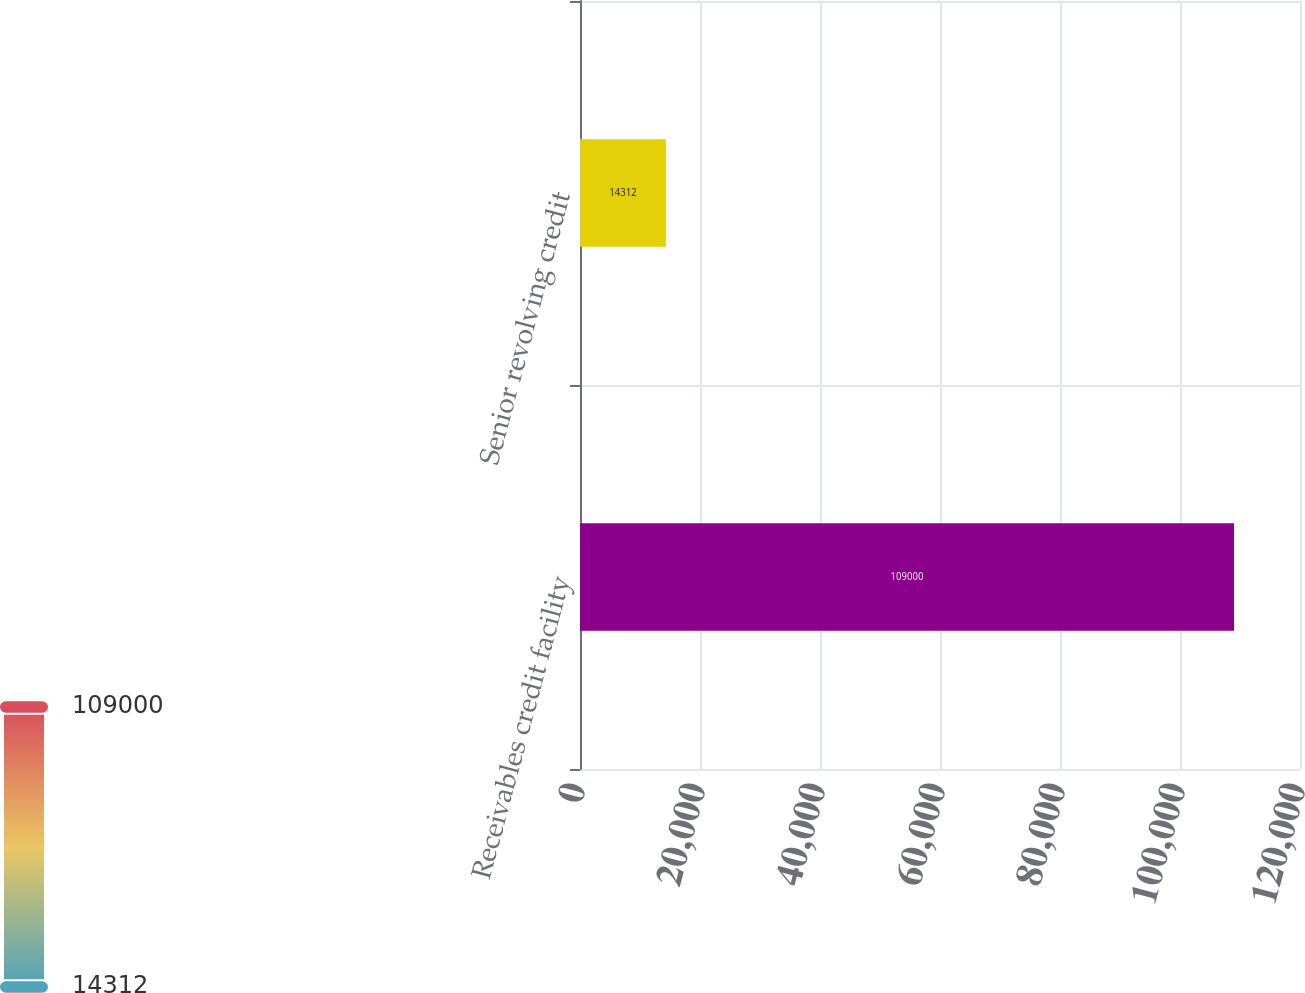Convert chart to OTSL. <chart><loc_0><loc_0><loc_500><loc_500><bar_chart><fcel>Receivables credit facility<fcel>Senior revolving credit<nl><fcel>109000<fcel>14312<nl></chart> 